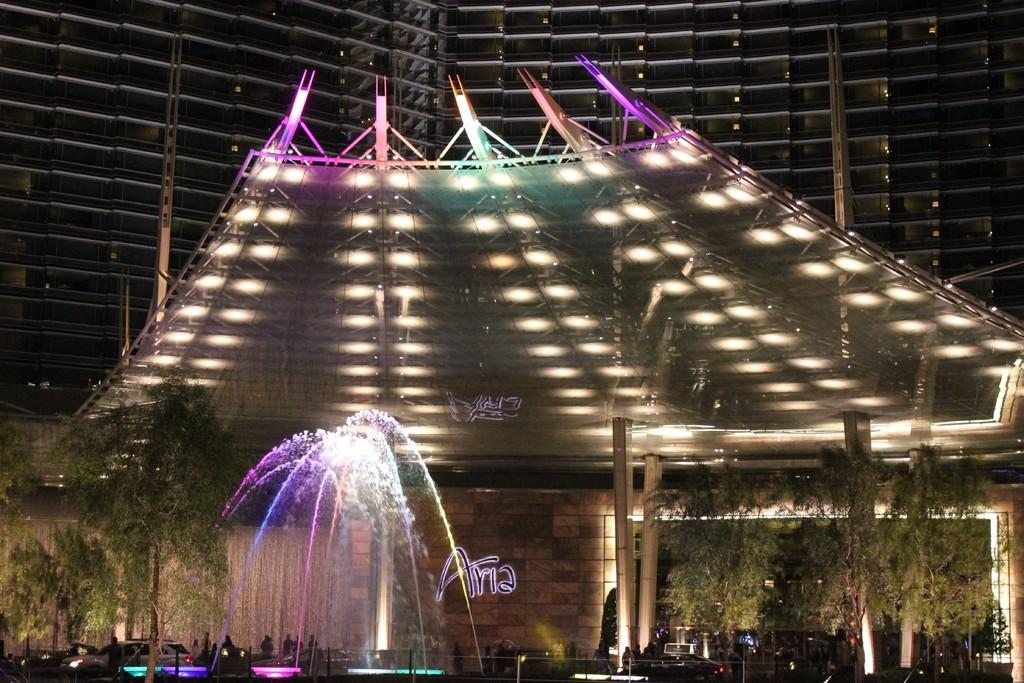What type of structure can be seen in the image? There is a building in the image. What is another feature visible in the image? There is a water fountain in the image. What natural elements are present in the image? There are many trees in the image. What man-made objects can be seen in the image? There are vehicles in the image. Are there any living beings in the image? Yes, there are people in the image. What type of signage is present in the image? There is an LED text in the image. Where is the zoo located in the image? There is no zoo present in the image. What type of volleyball game is being played in the image? There is no volleyball game present in the image. 